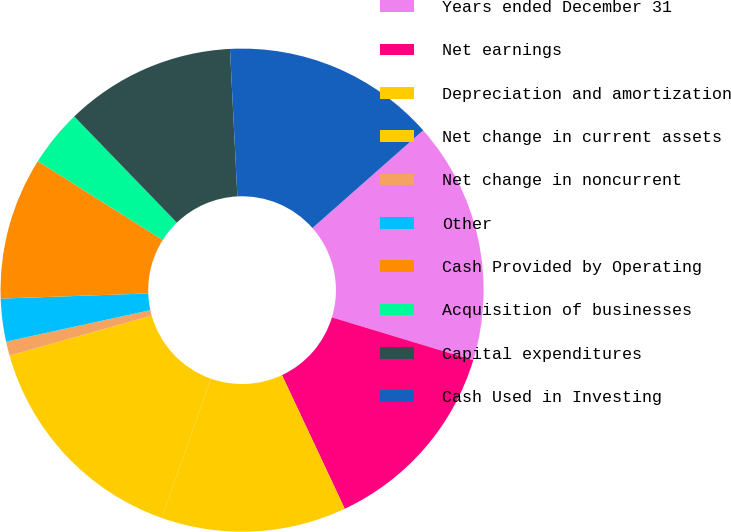Convert chart to OTSL. <chart><loc_0><loc_0><loc_500><loc_500><pie_chart><fcel>Years ended December 31<fcel>Net earnings<fcel>Depreciation and amortization<fcel>Net change in current assets<fcel>Net change in noncurrent<fcel>Other<fcel>Cash Provided by Operating<fcel>Acquisition of businesses<fcel>Capital expenditures<fcel>Cash Used in Investing<nl><fcel>16.19%<fcel>13.33%<fcel>12.38%<fcel>15.24%<fcel>0.95%<fcel>2.86%<fcel>9.52%<fcel>3.81%<fcel>11.43%<fcel>14.29%<nl></chart> 